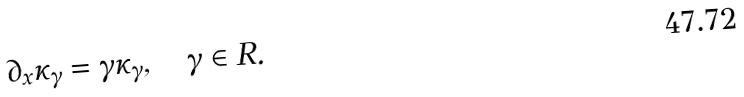<formula> <loc_0><loc_0><loc_500><loc_500>\partial _ { x } \kappa _ { \gamma } = \gamma \kappa _ { \gamma } , \quad \gamma \in R .</formula> 